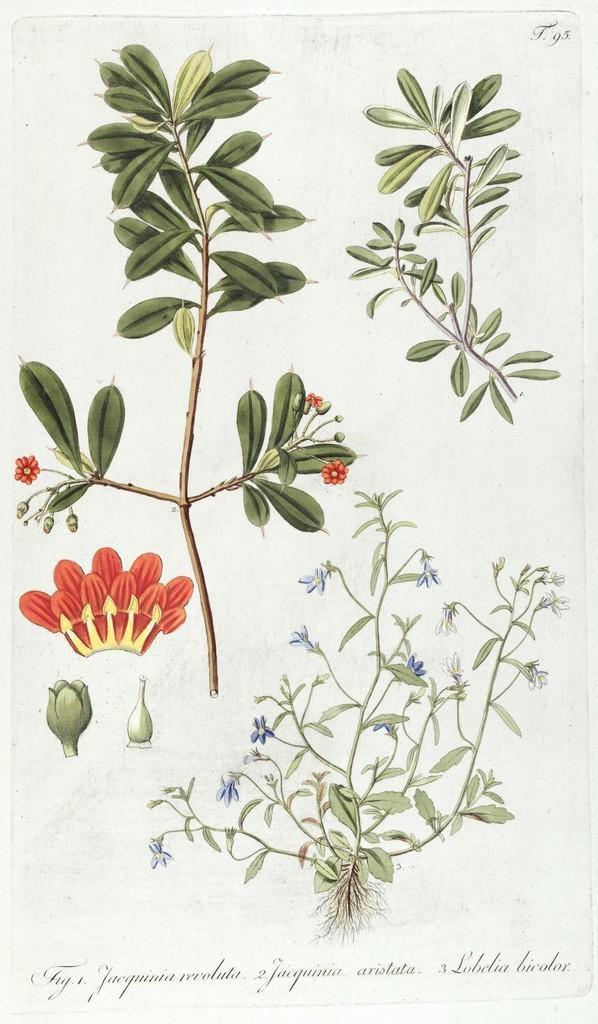How would you summarize this image in a sentence or two? In this image we can see painting of plants with flowers and some text. 